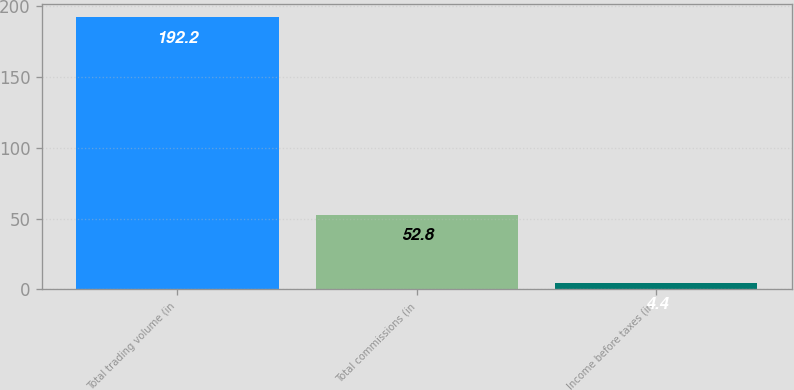<chart> <loc_0><loc_0><loc_500><loc_500><bar_chart><fcel>Total trading volume (in<fcel>Total commissions (in<fcel>Income before taxes (in<nl><fcel>192.2<fcel>52.8<fcel>4.4<nl></chart> 